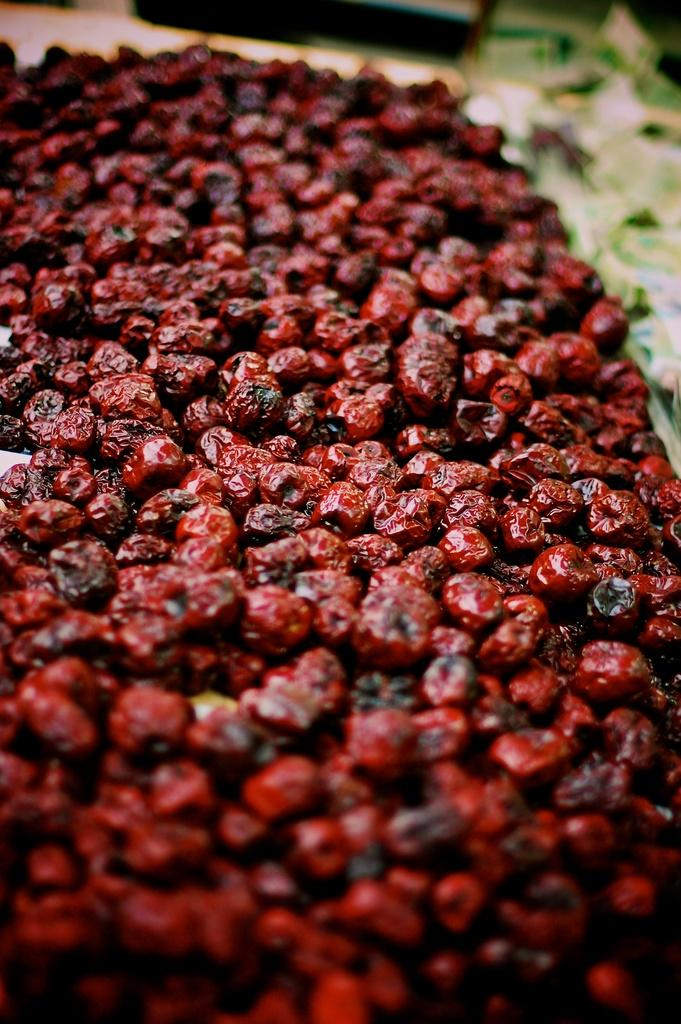What type of food is visible in the image? There are many fruits in the image. Can you describe the objects at the top of the image? Unfortunately, there is not enough information provided to describe the objects at the top of the image. What type of road can be seen in the image? There is no road present in the image; it features many fruits. How does the society depicted in the image contribute to the overall theme? There is no society depicted in the image; it only features many fruits. 